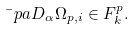Convert formula to latex. <formula><loc_0><loc_0><loc_500><loc_500>\bar { \ } p a D _ { \alpha } \Omega _ { p , i } \in F _ { k } ^ { p } .</formula> 